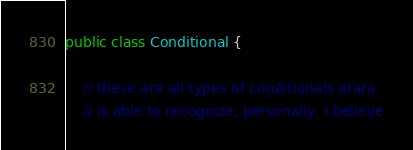Convert code to text. <code><loc_0><loc_0><loc_500><loc_500><_Java_>public class Conditional {

    // these are all types of conditionals arara
    // is able to recognize; personally, I believe</code> 